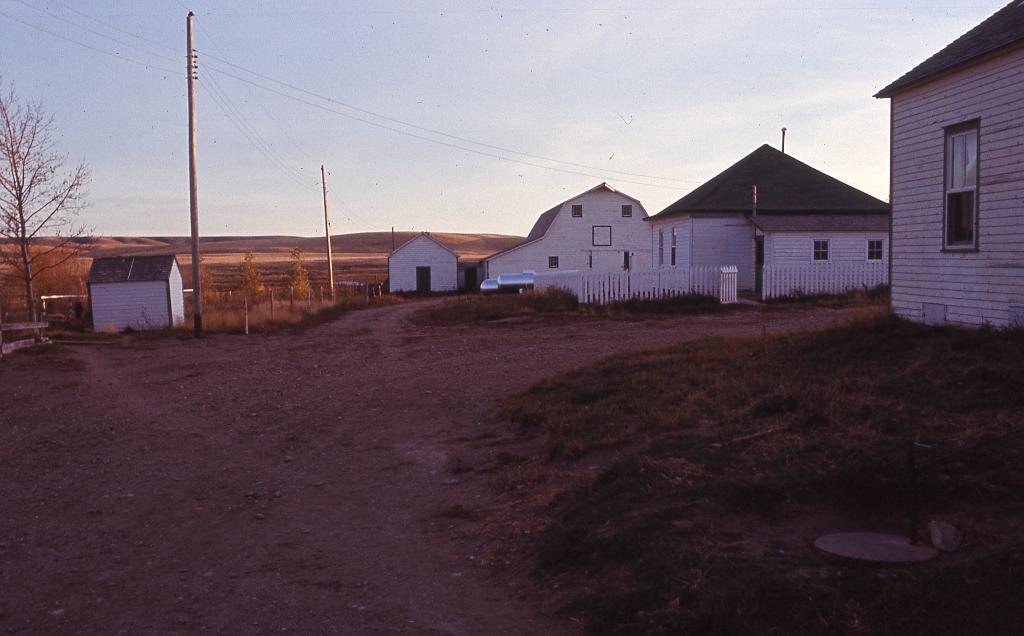Could you give a brief overview of what you see in this image? In this picture I can see buildings, poles, cables, fence, trees, and in the background there is the sky. 